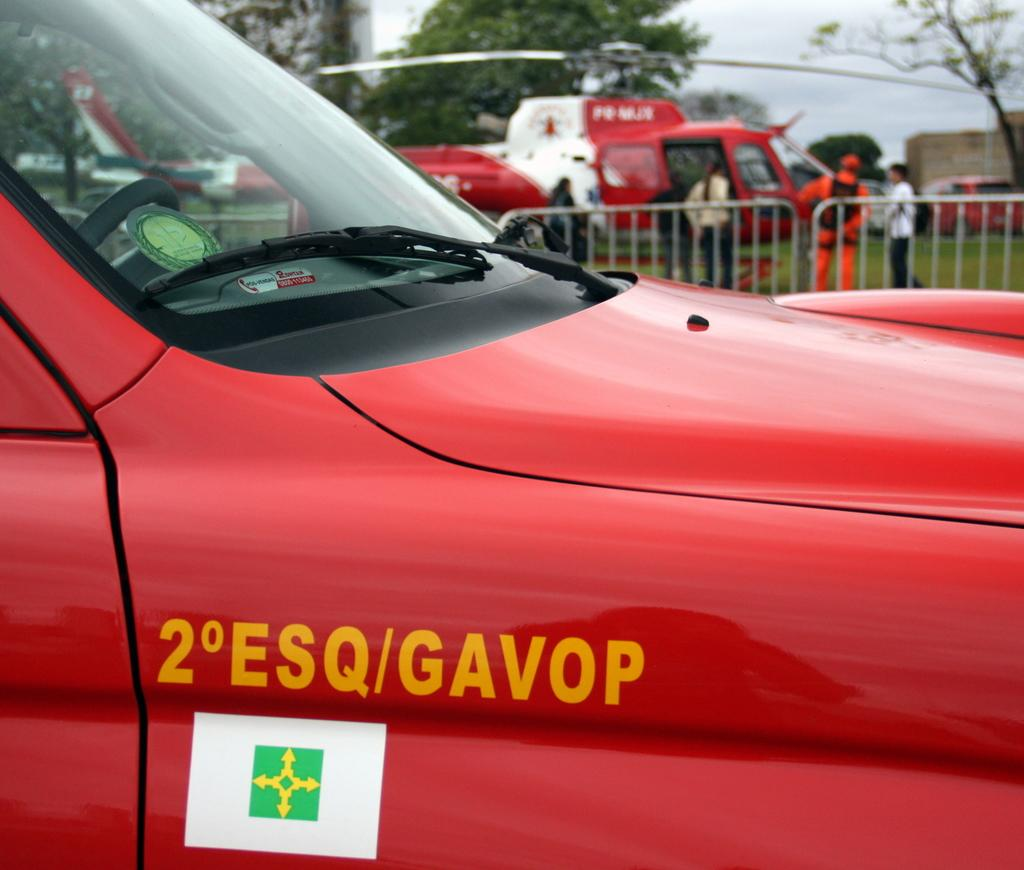<image>
Relay a brief, clear account of the picture shown. A red vehicle has 2 ESQ/GAVOP painted on the right side. 